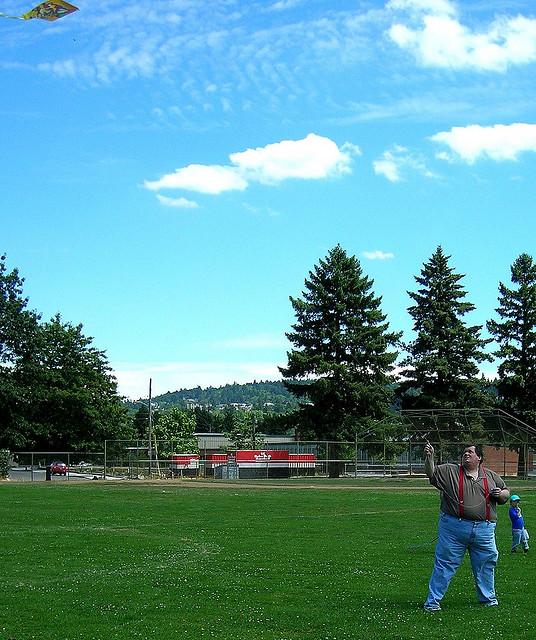Is it sunny?
Be succinct. Yes. What's the weather like in the picture?
Quick response, please. Sunny. How many trees are in the background?
Write a very short answer. 4. Is the man wearing a belt?
Give a very brief answer. No. Did one of the guys just take off his shirt?
Answer briefly. No. 